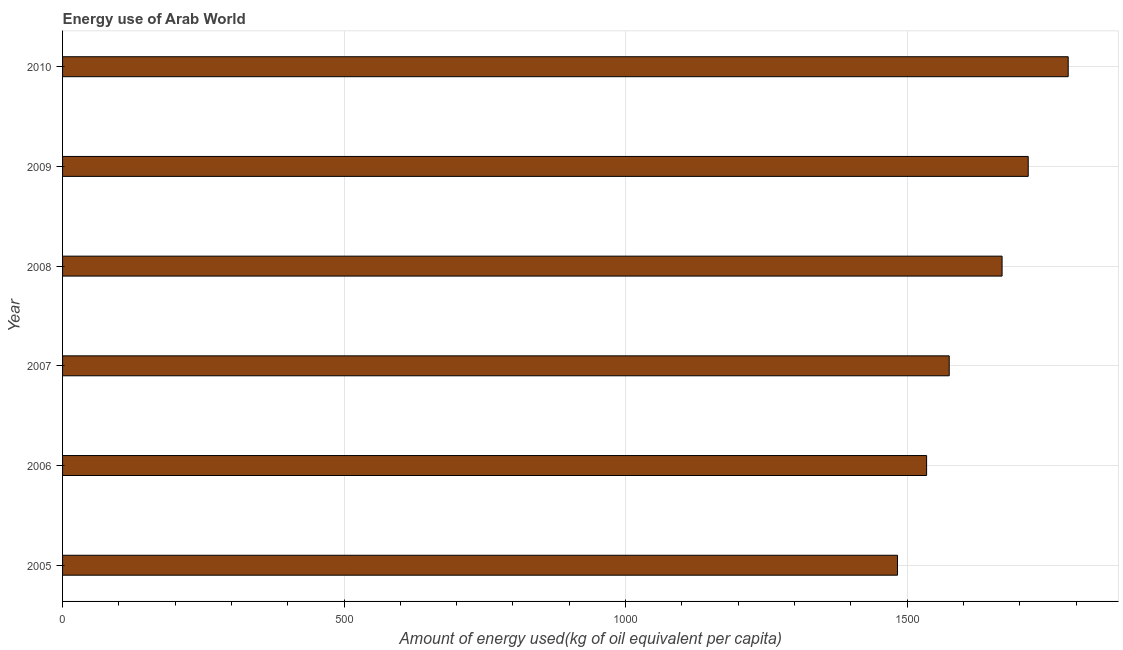Does the graph contain grids?
Provide a short and direct response. Yes. What is the title of the graph?
Offer a very short reply. Energy use of Arab World. What is the label or title of the X-axis?
Provide a short and direct response. Amount of energy used(kg of oil equivalent per capita). What is the label or title of the Y-axis?
Make the answer very short. Year. What is the amount of energy used in 2006?
Your response must be concise. 1534.62. Across all years, what is the maximum amount of energy used?
Offer a very short reply. 1786.13. Across all years, what is the minimum amount of energy used?
Give a very brief answer. 1482.94. In which year was the amount of energy used maximum?
Provide a short and direct response. 2010. In which year was the amount of energy used minimum?
Provide a short and direct response. 2005. What is the sum of the amount of energy used?
Your answer should be very brief. 9762.24. What is the difference between the amount of energy used in 2006 and 2009?
Keep it short and to the point. -180.48. What is the average amount of energy used per year?
Offer a very short reply. 1627.04. What is the median amount of energy used?
Keep it short and to the point. 1621.73. What is the ratio of the amount of energy used in 2006 to that in 2009?
Ensure brevity in your answer.  0.9. What is the difference between the highest and the second highest amount of energy used?
Make the answer very short. 71.03. What is the difference between the highest and the lowest amount of energy used?
Your response must be concise. 303.18. How many bars are there?
Your answer should be compact. 6. Are all the bars in the graph horizontal?
Your answer should be compact. Yes. How many years are there in the graph?
Your response must be concise. 6. What is the Amount of energy used(kg of oil equivalent per capita) in 2005?
Ensure brevity in your answer.  1482.94. What is the Amount of energy used(kg of oil equivalent per capita) of 2006?
Give a very brief answer. 1534.62. What is the Amount of energy used(kg of oil equivalent per capita) of 2007?
Your answer should be compact. 1574.79. What is the Amount of energy used(kg of oil equivalent per capita) of 2008?
Your answer should be compact. 1668.66. What is the Amount of energy used(kg of oil equivalent per capita) in 2009?
Provide a short and direct response. 1715.1. What is the Amount of energy used(kg of oil equivalent per capita) of 2010?
Make the answer very short. 1786.13. What is the difference between the Amount of energy used(kg of oil equivalent per capita) in 2005 and 2006?
Ensure brevity in your answer.  -51.68. What is the difference between the Amount of energy used(kg of oil equivalent per capita) in 2005 and 2007?
Provide a short and direct response. -91.85. What is the difference between the Amount of energy used(kg of oil equivalent per capita) in 2005 and 2008?
Offer a terse response. -185.72. What is the difference between the Amount of energy used(kg of oil equivalent per capita) in 2005 and 2009?
Offer a terse response. -232.15. What is the difference between the Amount of energy used(kg of oil equivalent per capita) in 2005 and 2010?
Your response must be concise. -303.18. What is the difference between the Amount of energy used(kg of oil equivalent per capita) in 2006 and 2007?
Give a very brief answer. -40.17. What is the difference between the Amount of energy used(kg of oil equivalent per capita) in 2006 and 2008?
Offer a terse response. -134.04. What is the difference between the Amount of energy used(kg of oil equivalent per capita) in 2006 and 2009?
Give a very brief answer. -180.48. What is the difference between the Amount of energy used(kg of oil equivalent per capita) in 2006 and 2010?
Ensure brevity in your answer.  -251.51. What is the difference between the Amount of energy used(kg of oil equivalent per capita) in 2007 and 2008?
Offer a very short reply. -93.87. What is the difference between the Amount of energy used(kg of oil equivalent per capita) in 2007 and 2009?
Offer a terse response. -140.31. What is the difference between the Amount of energy used(kg of oil equivalent per capita) in 2007 and 2010?
Provide a short and direct response. -211.34. What is the difference between the Amount of energy used(kg of oil equivalent per capita) in 2008 and 2009?
Your response must be concise. -46.44. What is the difference between the Amount of energy used(kg of oil equivalent per capita) in 2008 and 2010?
Keep it short and to the point. -117.47. What is the difference between the Amount of energy used(kg of oil equivalent per capita) in 2009 and 2010?
Offer a terse response. -71.03. What is the ratio of the Amount of energy used(kg of oil equivalent per capita) in 2005 to that in 2007?
Give a very brief answer. 0.94. What is the ratio of the Amount of energy used(kg of oil equivalent per capita) in 2005 to that in 2008?
Your response must be concise. 0.89. What is the ratio of the Amount of energy used(kg of oil equivalent per capita) in 2005 to that in 2009?
Make the answer very short. 0.86. What is the ratio of the Amount of energy used(kg of oil equivalent per capita) in 2005 to that in 2010?
Provide a short and direct response. 0.83. What is the ratio of the Amount of energy used(kg of oil equivalent per capita) in 2006 to that in 2008?
Offer a terse response. 0.92. What is the ratio of the Amount of energy used(kg of oil equivalent per capita) in 2006 to that in 2009?
Your response must be concise. 0.9. What is the ratio of the Amount of energy used(kg of oil equivalent per capita) in 2006 to that in 2010?
Provide a short and direct response. 0.86. What is the ratio of the Amount of energy used(kg of oil equivalent per capita) in 2007 to that in 2008?
Offer a terse response. 0.94. What is the ratio of the Amount of energy used(kg of oil equivalent per capita) in 2007 to that in 2009?
Offer a very short reply. 0.92. What is the ratio of the Amount of energy used(kg of oil equivalent per capita) in 2007 to that in 2010?
Keep it short and to the point. 0.88. What is the ratio of the Amount of energy used(kg of oil equivalent per capita) in 2008 to that in 2009?
Keep it short and to the point. 0.97. What is the ratio of the Amount of energy used(kg of oil equivalent per capita) in 2008 to that in 2010?
Make the answer very short. 0.93. 